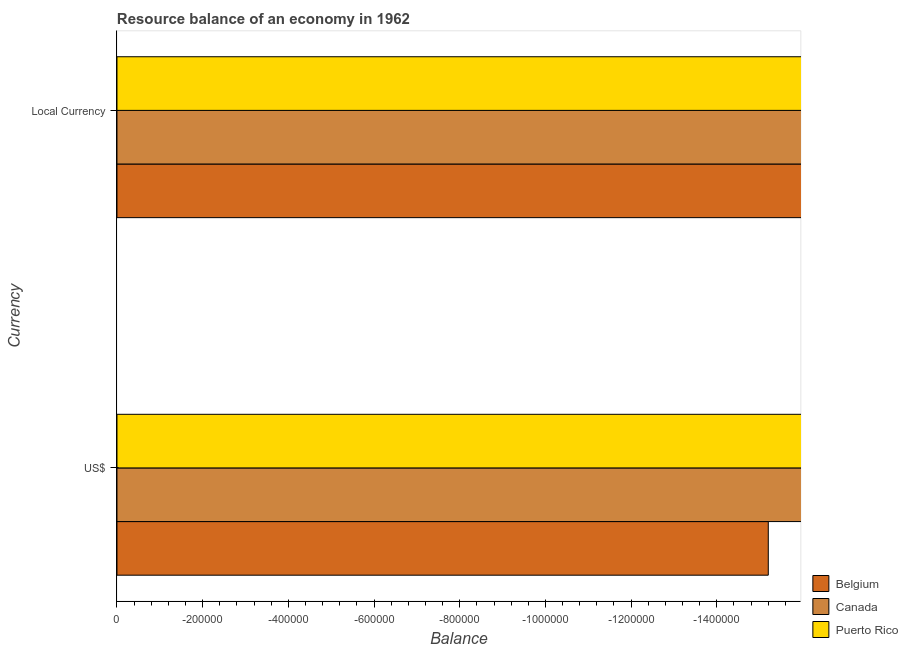Are the number of bars per tick equal to the number of legend labels?
Make the answer very short. No. Are the number of bars on each tick of the Y-axis equal?
Offer a terse response. Yes. How many bars are there on the 1st tick from the top?
Provide a succinct answer. 0. What is the label of the 2nd group of bars from the top?
Provide a succinct answer. US$. Across all countries, what is the minimum resource balance in constant us$?
Make the answer very short. 0. What is the difference between the resource balance in us$ in Puerto Rico and the resource balance in constant us$ in Belgium?
Your answer should be very brief. 0. In how many countries, is the resource balance in constant us$ greater than the average resource balance in constant us$ taken over all countries?
Your response must be concise. 0. What is the difference between two consecutive major ticks on the X-axis?
Make the answer very short. 2.00e+05. Are the values on the major ticks of X-axis written in scientific E-notation?
Your response must be concise. No. Does the graph contain grids?
Ensure brevity in your answer.  No. How are the legend labels stacked?
Provide a short and direct response. Vertical. What is the title of the graph?
Provide a succinct answer. Resource balance of an economy in 1962. What is the label or title of the X-axis?
Provide a succinct answer. Balance. What is the label or title of the Y-axis?
Provide a succinct answer. Currency. What is the Balance in Puerto Rico in US$?
Offer a very short reply. 0. What is the Balance of Belgium in Local Currency?
Make the answer very short. 0. What is the Balance in Puerto Rico in Local Currency?
Your answer should be compact. 0. What is the total Balance of Canada in the graph?
Ensure brevity in your answer.  0. What is the average Balance of Belgium per Currency?
Offer a terse response. 0. What is the average Balance of Puerto Rico per Currency?
Your answer should be compact. 0. 